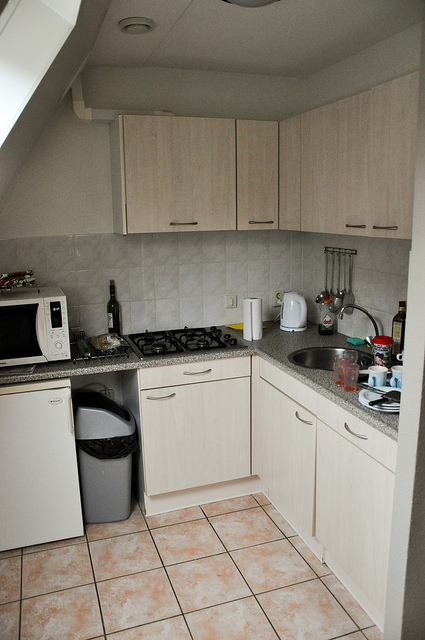<image>What color plate is on top of the microwave? I am not sure what color the plate on top of the microwave is. The answers suggest it could be black, gray, silver, white or spotted. What color plate is on top of the microwave? I don't know what color plate is on top of the microwave. 